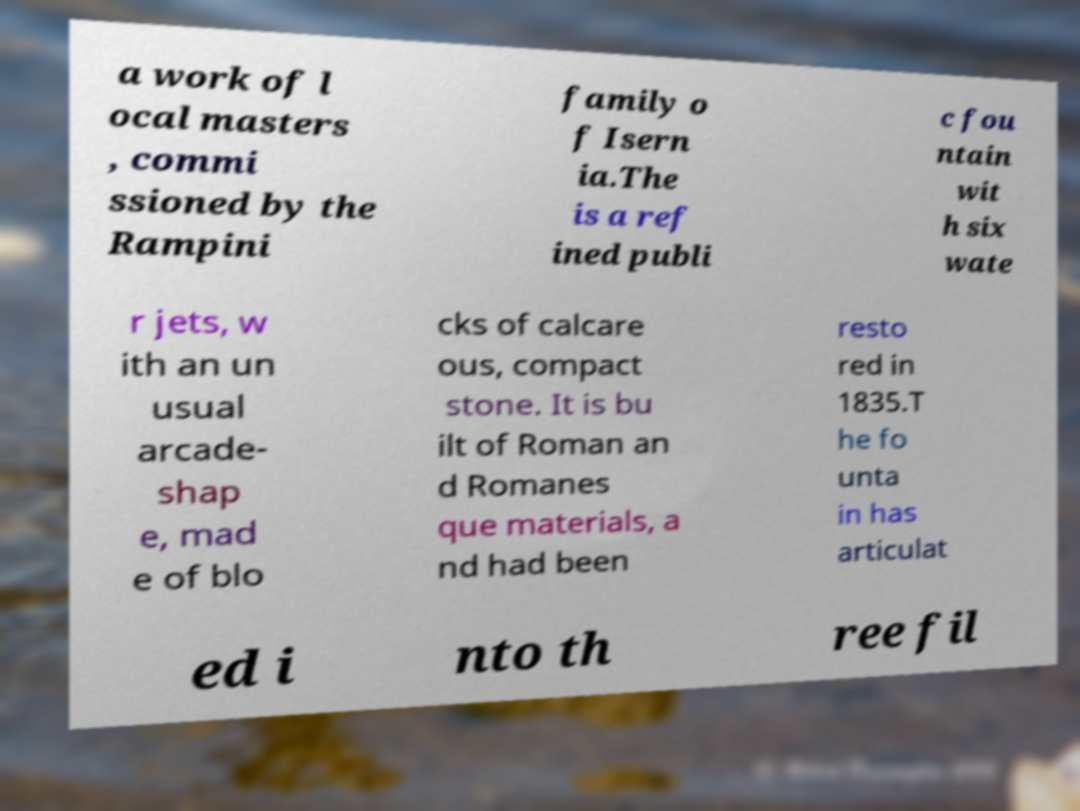Could you extract and type out the text from this image? a work of l ocal masters , commi ssioned by the Rampini family o f Isern ia.The is a ref ined publi c fou ntain wit h six wate r jets, w ith an un usual arcade- shap e, mad e of blo cks of calcare ous, compact stone. It is bu ilt of Roman an d Romanes que materials, a nd had been resto red in 1835.T he fo unta in has articulat ed i nto th ree fil 